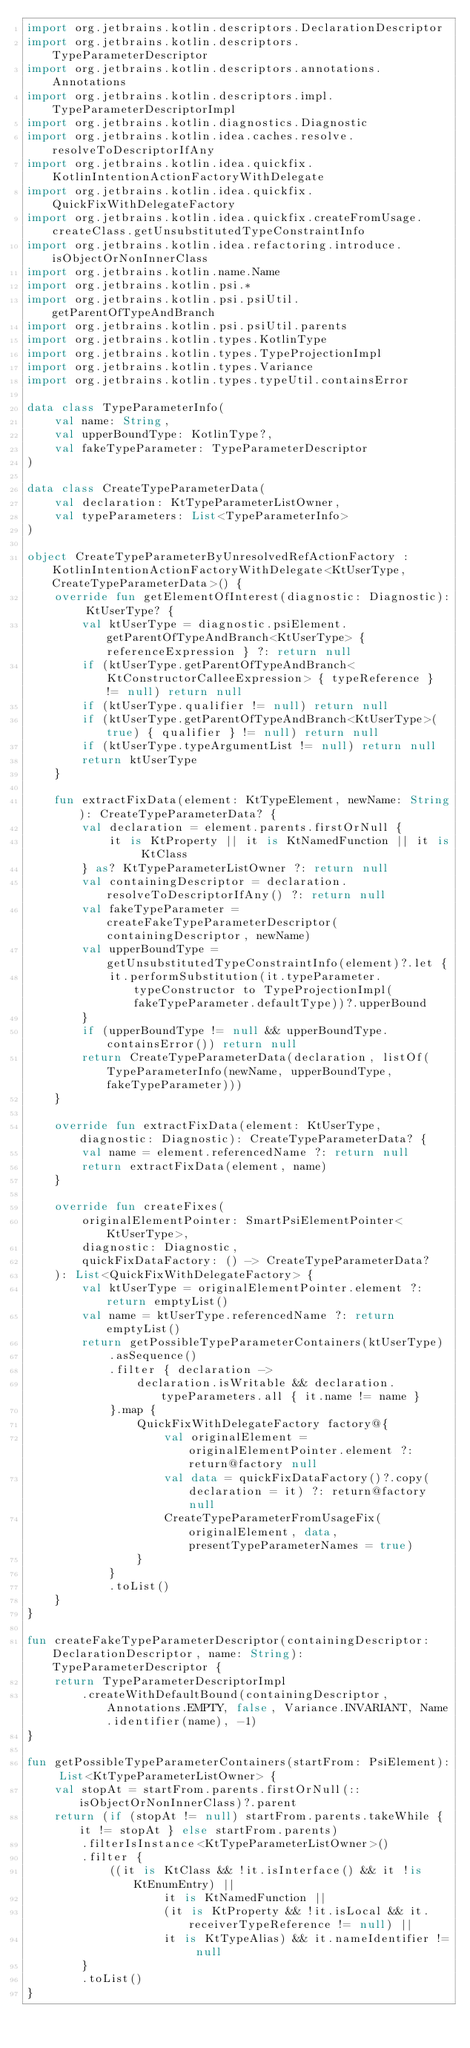Convert code to text. <code><loc_0><loc_0><loc_500><loc_500><_Kotlin_>import org.jetbrains.kotlin.descriptors.DeclarationDescriptor
import org.jetbrains.kotlin.descriptors.TypeParameterDescriptor
import org.jetbrains.kotlin.descriptors.annotations.Annotations
import org.jetbrains.kotlin.descriptors.impl.TypeParameterDescriptorImpl
import org.jetbrains.kotlin.diagnostics.Diagnostic
import org.jetbrains.kotlin.idea.caches.resolve.resolveToDescriptorIfAny
import org.jetbrains.kotlin.idea.quickfix.KotlinIntentionActionFactoryWithDelegate
import org.jetbrains.kotlin.idea.quickfix.QuickFixWithDelegateFactory
import org.jetbrains.kotlin.idea.quickfix.createFromUsage.createClass.getUnsubstitutedTypeConstraintInfo
import org.jetbrains.kotlin.idea.refactoring.introduce.isObjectOrNonInnerClass
import org.jetbrains.kotlin.name.Name
import org.jetbrains.kotlin.psi.*
import org.jetbrains.kotlin.psi.psiUtil.getParentOfTypeAndBranch
import org.jetbrains.kotlin.psi.psiUtil.parents
import org.jetbrains.kotlin.types.KotlinType
import org.jetbrains.kotlin.types.TypeProjectionImpl
import org.jetbrains.kotlin.types.Variance
import org.jetbrains.kotlin.types.typeUtil.containsError

data class TypeParameterInfo(
    val name: String,
    val upperBoundType: KotlinType?,
    val fakeTypeParameter: TypeParameterDescriptor
)

data class CreateTypeParameterData(
    val declaration: KtTypeParameterListOwner,
    val typeParameters: List<TypeParameterInfo>
)

object CreateTypeParameterByUnresolvedRefActionFactory : KotlinIntentionActionFactoryWithDelegate<KtUserType, CreateTypeParameterData>() {
    override fun getElementOfInterest(diagnostic: Diagnostic): KtUserType? {
        val ktUserType = diagnostic.psiElement.getParentOfTypeAndBranch<KtUserType> { referenceExpression } ?: return null
        if (ktUserType.getParentOfTypeAndBranch<KtConstructorCalleeExpression> { typeReference } != null) return null
        if (ktUserType.qualifier != null) return null
        if (ktUserType.getParentOfTypeAndBranch<KtUserType>(true) { qualifier } != null) return null
        if (ktUserType.typeArgumentList != null) return null
        return ktUserType
    }

    fun extractFixData(element: KtTypeElement, newName: String): CreateTypeParameterData? {
        val declaration = element.parents.firstOrNull {
            it is KtProperty || it is KtNamedFunction || it is KtClass
        } as? KtTypeParameterListOwner ?: return null
        val containingDescriptor = declaration.resolveToDescriptorIfAny() ?: return null
        val fakeTypeParameter = createFakeTypeParameterDescriptor(containingDescriptor, newName)
        val upperBoundType = getUnsubstitutedTypeConstraintInfo(element)?.let {
            it.performSubstitution(it.typeParameter.typeConstructor to TypeProjectionImpl(fakeTypeParameter.defaultType))?.upperBound
        }
        if (upperBoundType != null && upperBoundType.containsError()) return null
        return CreateTypeParameterData(declaration, listOf(TypeParameterInfo(newName, upperBoundType, fakeTypeParameter)))
    }

    override fun extractFixData(element: KtUserType, diagnostic: Diagnostic): CreateTypeParameterData? {
        val name = element.referencedName ?: return null
        return extractFixData(element, name)
    }

    override fun createFixes(
        originalElementPointer: SmartPsiElementPointer<KtUserType>,
        diagnostic: Diagnostic,
        quickFixDataFactory: () -> CreateTypeParameterData?
    ): List<QuickFixWithDelegateFactory> {
        val ktUserType = originalElementPointer.element ?: return emptyList()
        val name = ktUserType.referencedName ?: return emptyList()
        return getPossibleTypeParameterContainers(ktUserType)
            .asSequence()
            .filter { declaration ->
                declaration.isWritable && declaration.typeParameters.all { it.name != name }
            }.map {
                QuickFixWithDelegateFactory factory@{
                    val originalElement = originalElementPointer.element ?: return@factory null
                    val data = quickFixDataFactory()?.copy(declaration = it) ?: return@factory null
                    CreateTypeParameterFromUsageFix(originalElement, data, presentTypeParameterNames = true)
                }
            }
            .toList()
    }
}

fun createFakeTypeParameterDescriptor(containingDescriptor: DeclarationDescriptor, name: String): TypeParameterDescriptor {
    return TypeParameterDescriptorImpl
        .createWithDefaultBound(containingDescriptor, Annotations.EMPTY, false, Variance.INVARIANT, Name.identifier(name), -1)
}

fun getPossibleTypeParameterContainers(startFrom: PsiElement): List<KtTypeParameterListOwner> {
    val stopAt = startFrom.parents.firstOrNull(::isObjectOrNonInnerClass)?.parent
    return (if (stopAt != null) startFrom.parents.takeWhile { it != stopAt } else startFrom.parents)
        .filterIsInstance<KtTypeParameterListOwner>()
        .filter {
            ((it is KtClass && !it.isInterface() && it !is KtEnumEntry) ||
                    it is KtNamedFunction ||
                    (it is KtProperty && !it.isLocal && it.receiverTypeReference != null) ||
                    it is KtTypeAlias) && it.nameIdentifier != null
        }
        .toList()
}</code> 